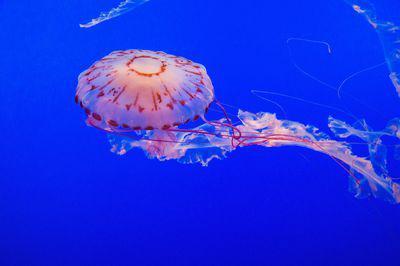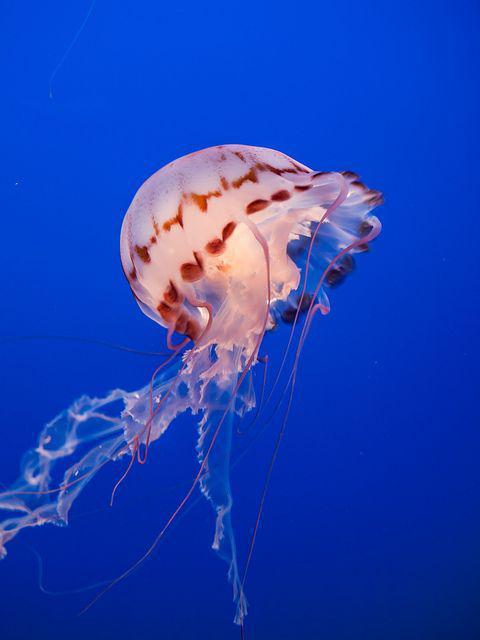The first image is the image on the left, the second image is the image on the right. For the images shown, is this caption "There are three jellyfish in total." true? Answer yes or no. No. 